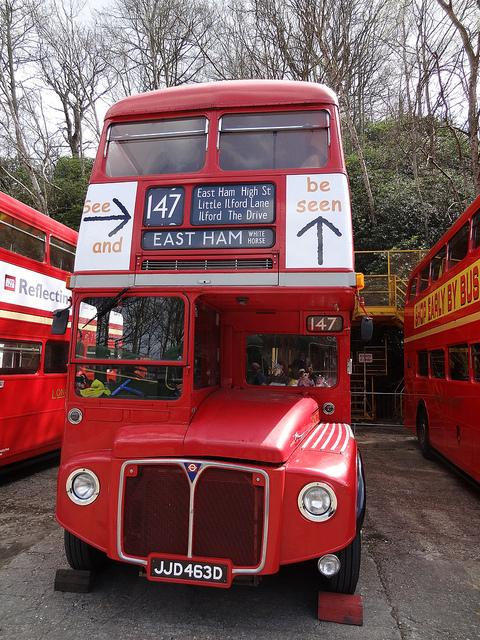What do the items in front of the tires here prevent? rolling 